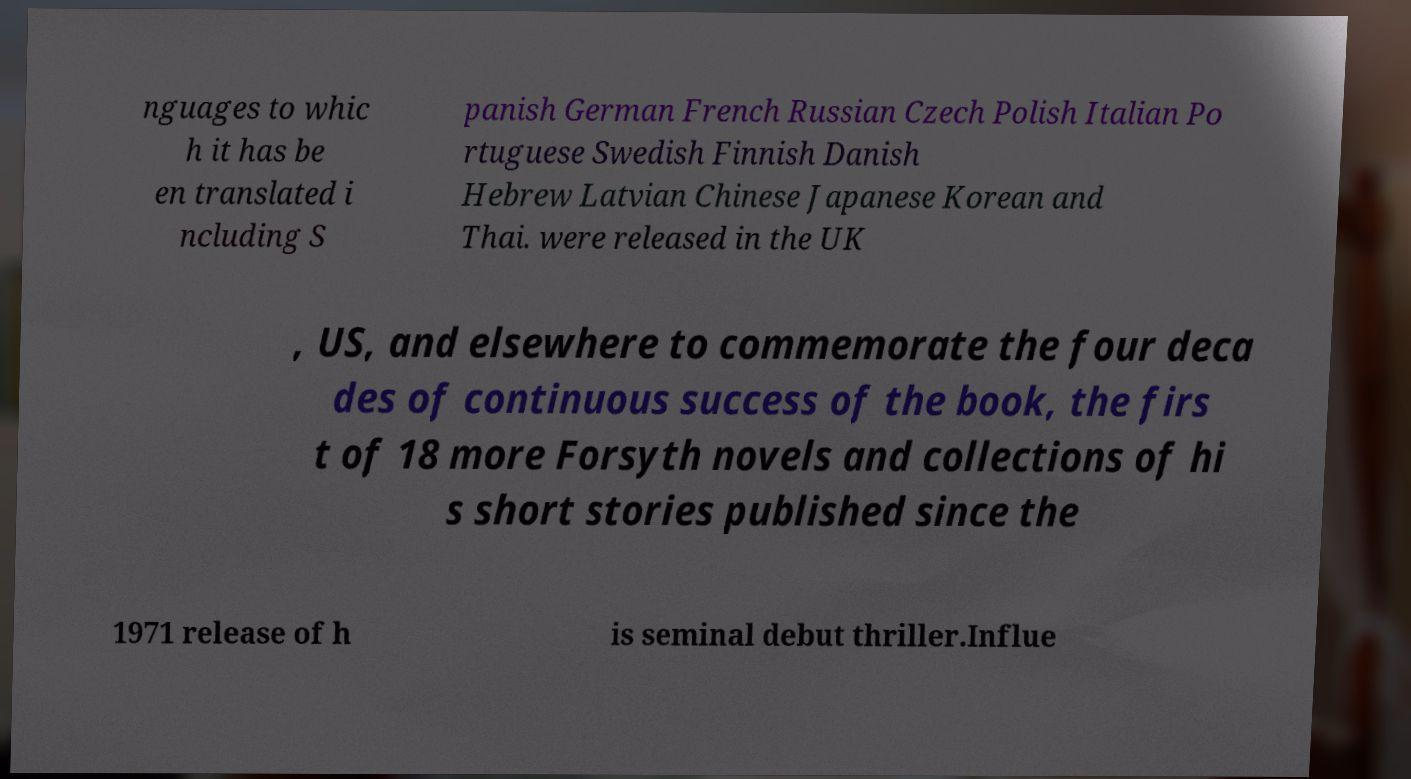Can you read and provide the text displayed in the image?This photo seems to have some interesting text. Can you extract and type it out for me? nguages to whic h it has be en translated i ncluding S panish German French Russian Czech Polish Italian Po rtuguese Swedish Finnish Danish Hebrew Latvian Chinese Japanese Korean and Thai. were released in the UK , US, and elsewhere to commemorate the four deca des of continuous success of the book, the firs t of 18 more Forsyth novels and collections of hi s short stories published since the 1971 release of h is seminal debut thriller.Influe 